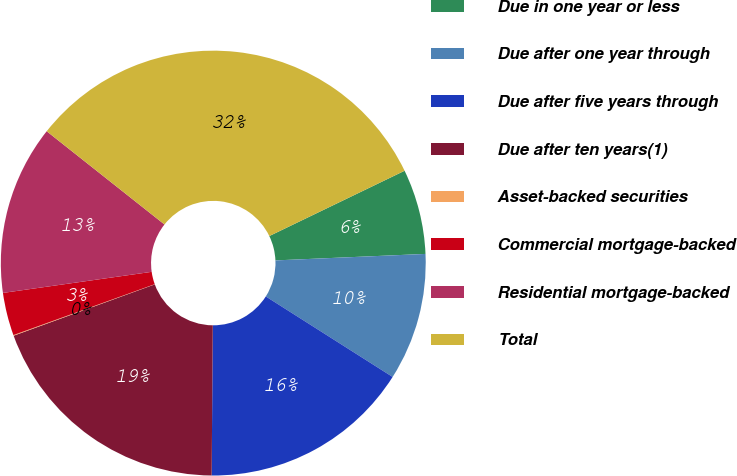Convert chart to OTSL. <chart><loc_0><loc_0><loc_500><loc_500><pie_chart><fcel>Due in one year or less<fcel>Due after one year through<fcel>Due after five years through<fcel>Due after ten years(1)<fcel>Asset-backed securities<fcel>Commercial mortgage-backed<fcel>Residential mortgage-backed<fcel>Total<nl><fcel>6.47%<fcel>9.69%<fcel>16.12%<fcel>19.33%<fcel>0.05%<fcel>3.26%<fcel>12.9%<fcel>32.19%<nl></chart> 